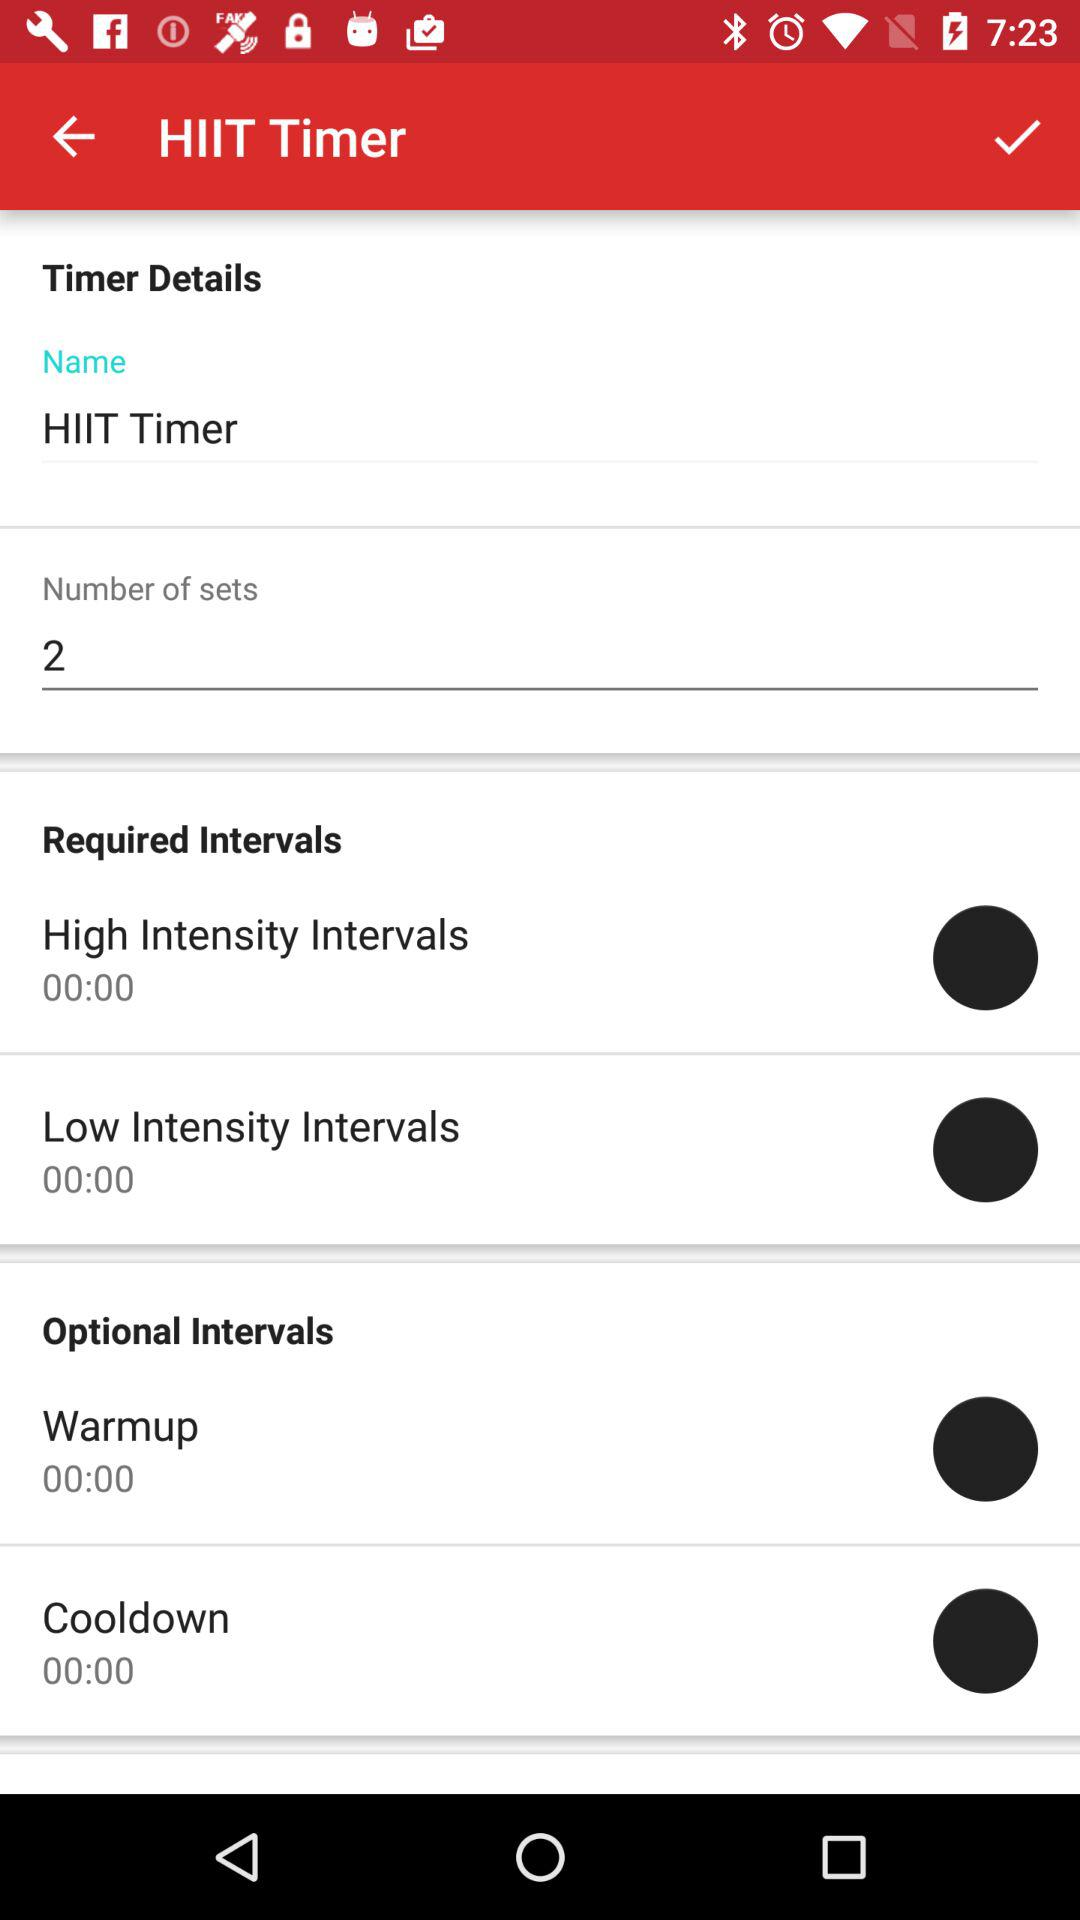What is the number of sets? The number of sets is 2. 